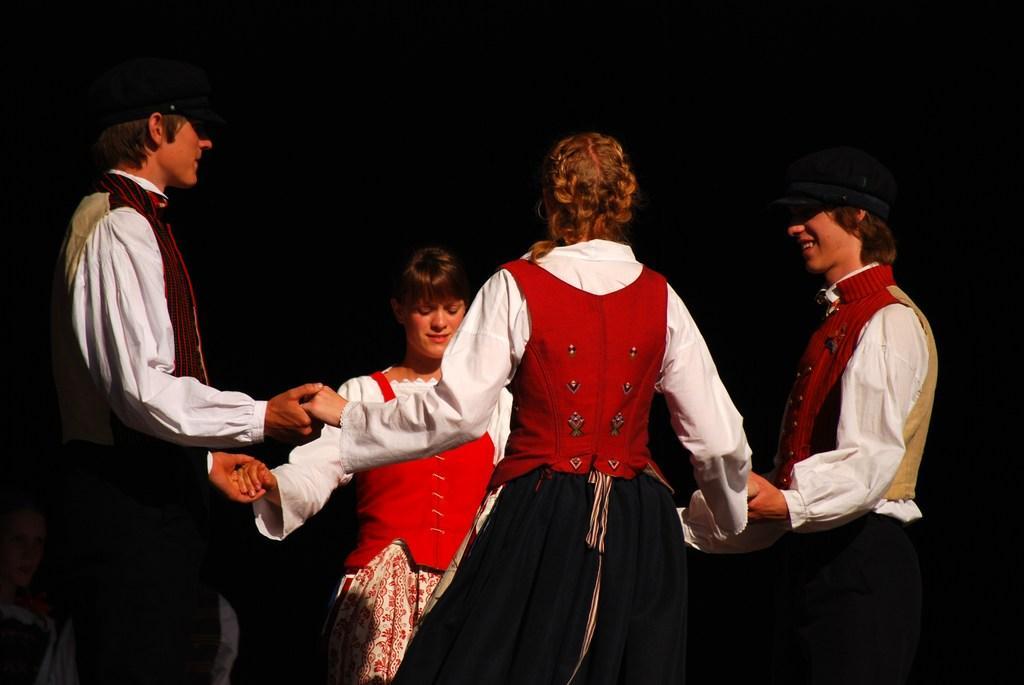Could you give a brief overview of what you see in this image? In this picture I can see four persons standing and holding each other hands, at the bottom left side of the image I can see a person , and there is dark background. 